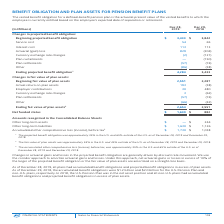According to Intel Corporation's financial document, What is the main driver of changes in actuarial gains and losses in the projected benefit obligation? Discount rate movement. The document states: "jected benefit obligation are generally driven by discount rate movement. We use the corridor approach to amortize actuarial gains and losses. Under t..." Also, What approach was used to amortize actuarial gains and loses? The corridor approach. The document states: "enerally driven by discount rate movement. We use the corridor approach to amortize actuarial gains and losses. Under this approach, net actuarial gai..." Also, What is the  Beginning projected benefit obligation for Dec 28, 2019? According to the financial document, $3,433 (in millions). The relevant text states: "Beginning projected benefit obligation $ 3,433 $ 3,842..." Also, can you calculate: How much is the ending projected benefit obligation outside of the US in 2018? Based on the calculation: 65% * 3,433 , the result is 2231.45 (in millions). This is based on the information: "Beginning projected benefit obligation $ 3,433 $ 3,842 Service cost 54 65..." The key data points involved are: 3,433, 65. Also, can you calculate: How much is the ending fair value of plan assets in the US in 2019? Based on the calculation: 55% * 2,654 , the result is 1459.7 (in millions). This is based on the information: "Ending fair value of plan assets 2 2,654 2,551 Ending fair value of plan assets 2 2,654 2,551..." The key data points involved are: 2,654, 55. Also, can you calculate: How much is the percentage change of the Net funded status from 2018 to 2019? To answer this question, I need to perform calculations using the financial data. The calculation is: (1,630 - 882) / 882 , which equals 84.81 (percentage). This is based on the information: "Net funded status $ 1,630 $ 882 Net funded status $ 1,630 $ 882..." The key data points involved are: 1,630, 882. 